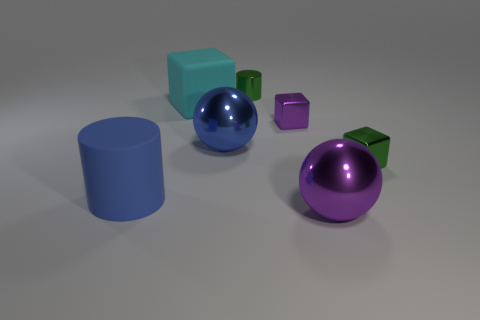Add 3 purple metallic things. How many objects exist? 10 Subtract all purple cubes. How many cubes are left? 2 Subtract all cyan matte cubes. How many cubes are left? 2 Subtract all blocks. How many objects are left? 4 Subtract 3 blocks. How many blocks are left? 0 Subtract all red balls. Subtract all gray cubes. How many balls are left? 2 Subtract all purple cubes. How many blue spheres are left? 1 Subtract all large matte objects. Subtract all small brown things. How many objects are left? 5 Add 2 cyan rubber things. How many cyan rubber things are left? 3 Add 5 tiny metallic blocks. How many tiny metallic blocks exist? 7 